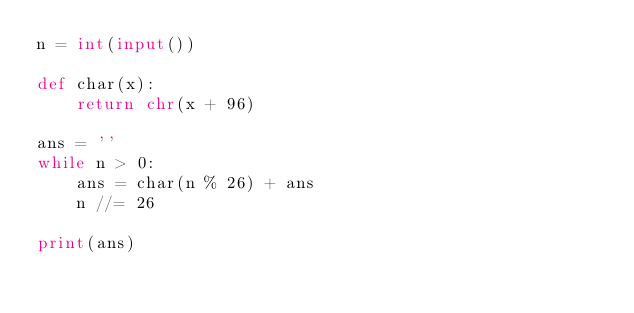<code> <loc_0><loc_0><loc_500><loc_500><_Python_>n = int(input())

def char(x):
    return chr(x + 96)

ans = ''
while n > 0:
    ans = char(n % 26) + ans
    n //= 26

print(ans)</code> 